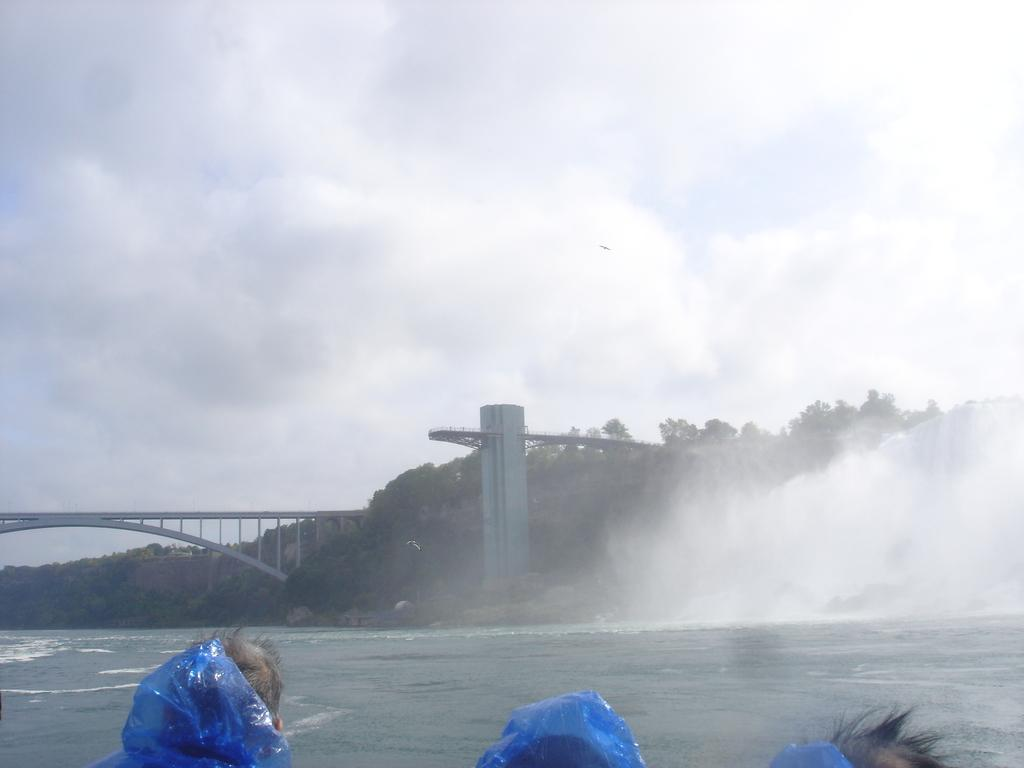How many people are in the image? There are three persons in the image. What is at the bottom of the image? There is water at the bottom of the image. What can be seen in the front of the image? There is a bridge and trees visible in the front of the image. What is visible in the sky at the top of the image? There are clouds in the sky at the top of the image. What is the rate of the train passing by in the image? There is no train present in the image, so it is not possible to determine the rate at which it would be passing by. 